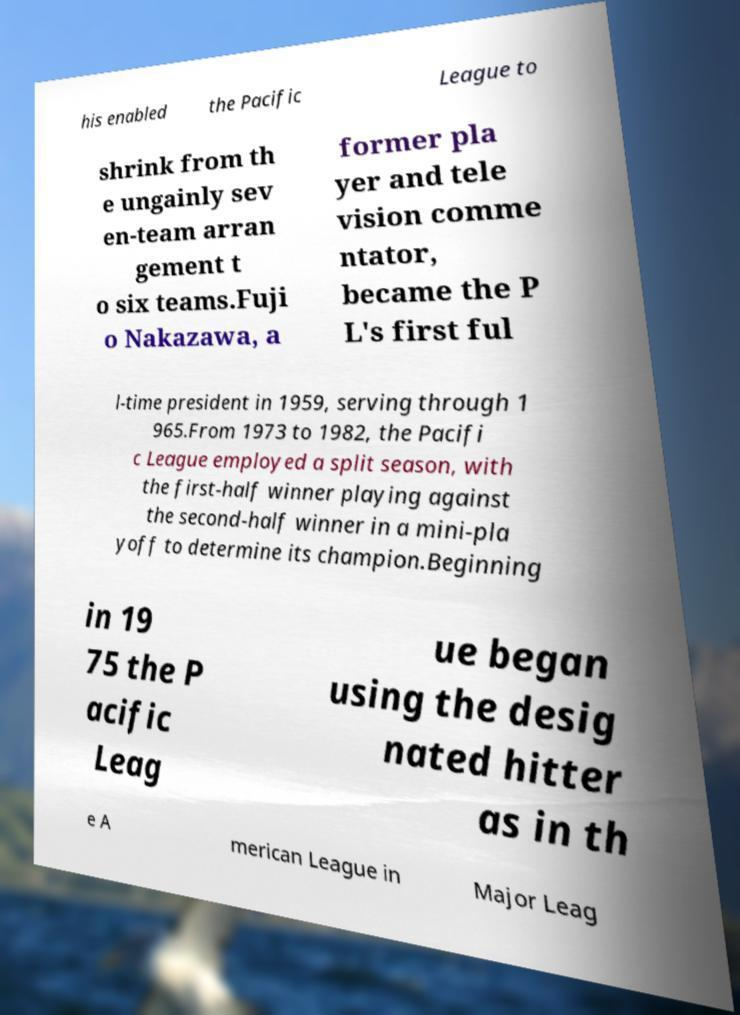Could you assist in decoding the text presented in this image and type it out clearly? his enabled the Pacific League to shrink from th e ungainly sev en-team arran gement t o six teams.Fuji o Nakazawa, a former pla yer and tele vision comme ntator, became the P L's first ful l-time president in 1959, serving through 1 965.From 1973 to 1982, the Pacifi c League employed a split season, with the first-half winner playing against the second-half winner in a mini-pla yoff to determine its champion.Beginning in 19 75 the P acific Leag ue began using the desig nated hitter as in th e A merican League in Major Leag 